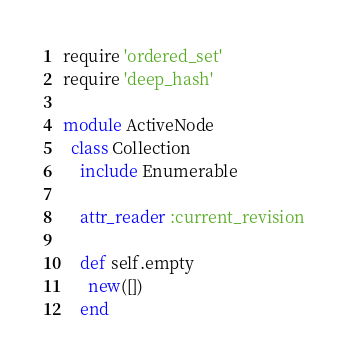<code> <loc_0><loc_0><loc_500><loc_500><_Ruby_>require 'ordered_set'
require 'deep_hash'

module ActiveNode
  class Collection
    include Enumerable

    attr_reader :current_revision

    def self.empty
      new([])
    end
</code> 